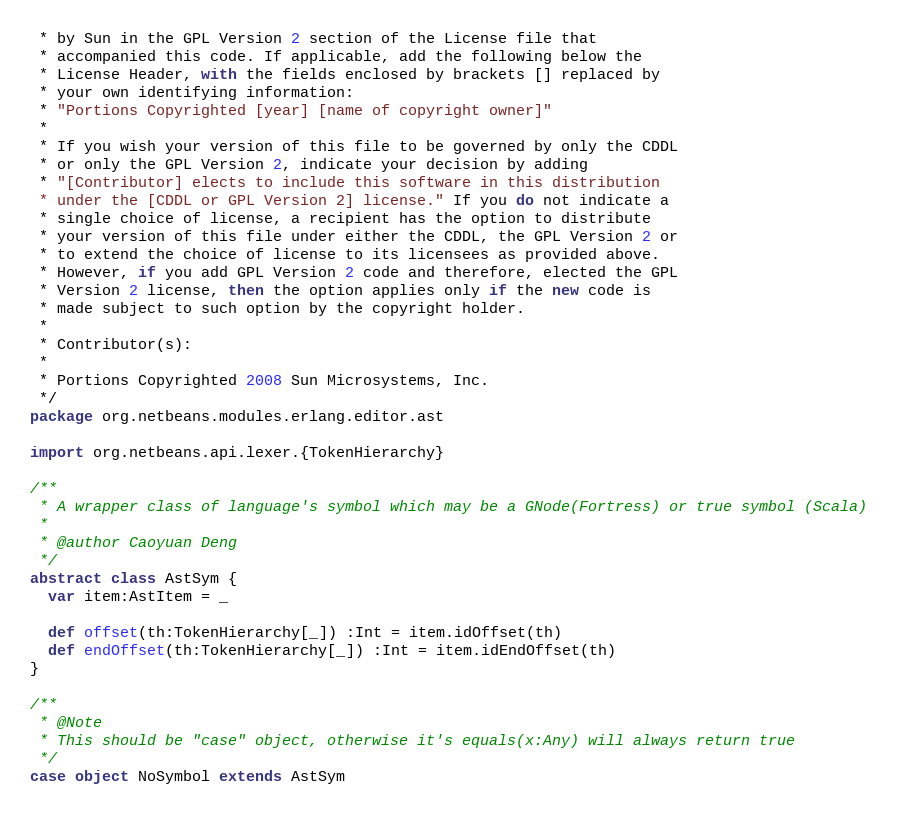Convert code to text. <code><loc_0><loc_0><loc_500><loc_500><_Scala_> * by Sun in the GPL Version 2 section of the License file that
 * accompanied this code. If applicable, add the following below the
 * License Header, with the fields enclosed by brackets [] replaced by
 * your own identifying information:
 * "Portions Copyrighted [year] [name of copyright owner]"
 *
 * If you wish your version of this file to be governed by only the CDDL
 * or only the GPL Version 2, indicate your decision by adding
 * "[Contributor] elects to include this software in this distribution
 * under the [CDDL or GPL Version 2] license." If you do not indicate a
 * single choice of license, a recipient has the option to distribute
 * your version of this file under either the CDDL, the GPL Version 2 or
 * to extend the choice of license to its licensees as provided above.
 * However, if you add GPL Version 2 code and therefore, elected the GPL
 * Version 2 license, then the option applies only if the new code is
 * made subject to such option by the copyright holder.
 *
 * Contributor(s):
 *
 * Portions Copyrighted 2008 Sun Microsystems, Inc.
 */
package org.netbeans.modules.erlang.editor.ast

import org.netbeans.api.lexer.{TokenHierarchy}

/**
 * A wrapper class of language's symbol which may be a GNode(Fortress) or true symbol (Scala)
 *
 * @author Caoyuan Deng
 */
abstract class AstSym {
  var item:AstItem = _
    
  def offset(th:TokenHierarchy[_]) :Int = item.idOffset(th)
  def endOffset(th:TokenHierarchy[_]) :Int = item.idEndOffset(th)
}

/**
 * @Note
 * This should be "case" object, otherwise it's equals(x:Any) will always return true
 */
case object NoSymbol extends AstSym
</code> 